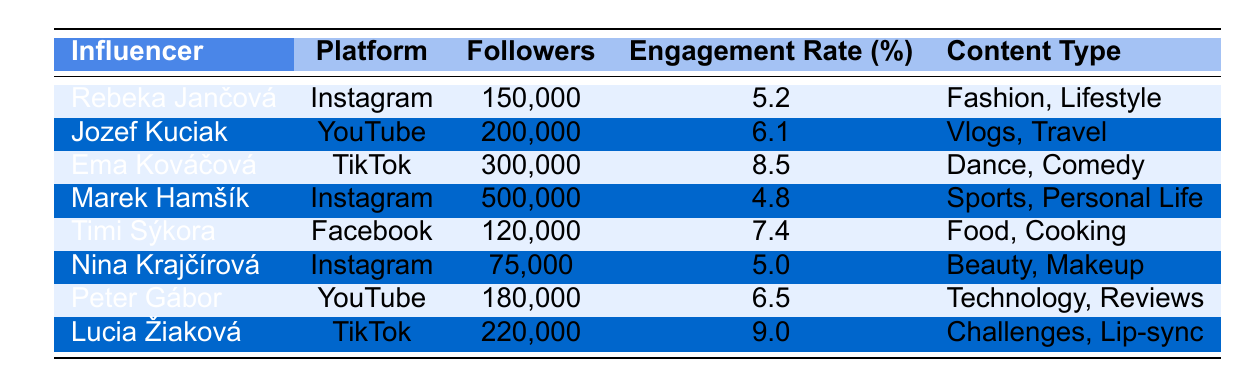What is the engagement rate of Rebeka Jančová? The engagement rate is listed directly in the row for Rebeka Jančová, which shows as 5.2%.
Answer: 5.2% Which influencer has the highest number of followers? By reviewing the "Followers" column, Marek Hamšík has the highest with 500,000 followers.
Answer: Marek Hamšík How many influencers have an engagement rate higher than 6%? From the table, Ema Kováčová (8.5%), Jozef Kuciak (6.1%), Peter Gábor (6.5%), and Lucia Žiaková (9.0%) have engagement rates higher than 6%. There are four influencers.
Answer: 4 What is the average engagement rate of the influencers listed? The engagement rates are: 5.2, 6.1, 8.5, 4.8, 7.4, 5.0, 6.5, and 9.0. Their sum is 52.5% and there are 8 influencers, so the average is 52.5/8 = 6.5625%.
Answer: 6.56% Is Ema Kováčová an influencer on Instagram? The table shows that Ema Kováčová is on TikTok, not Instagram.
Answer: No Which influencer has a lower engagement rate: Rebeka Jančová or Marek Hamšík? Rebeka Jančová (5.2%) has a higher engagement rate than Marek Hamšík (4.8%). Therefore, Marek Hamšík has a lower engagement rate.
Answer: Marek Hamšík If we were to combine the followers of all the influencers using TikTok, what would be the total? Ema Kováčová has 300,000 followers, and Lucia Žiaková has 220,000 followers on TikTok. The sum of these is 300,000 + 220,000 = 520,000.
Answer: 520,000 What percentage of the total number of followers do the influencers on Instagram have? On Instagram, Rebeka Jančová has 150,000 followers and Marek Hamšík has 500,000 followers, totaling 650,000. The total followers (150,000 + 200,000 + 300,000 + 500,000 + 120,000 + 75,000 + 180,000 + 220,000) is 1,645,000. The percentage is (650,000 / 1,645,000) * 100 = 39.5%.
Answer: 39.5% Which content type has the highest engagement rate, and what is that rate? Ema Kováčová with Dance, Comedy has the highest engagement rate of 8.5%.
Answer: Dance, Comedy - 8.5% Are there any influencers with the content type related to Food? Timi Sýkora is the only influencer with the content type related to Food.
Answer: Yes 